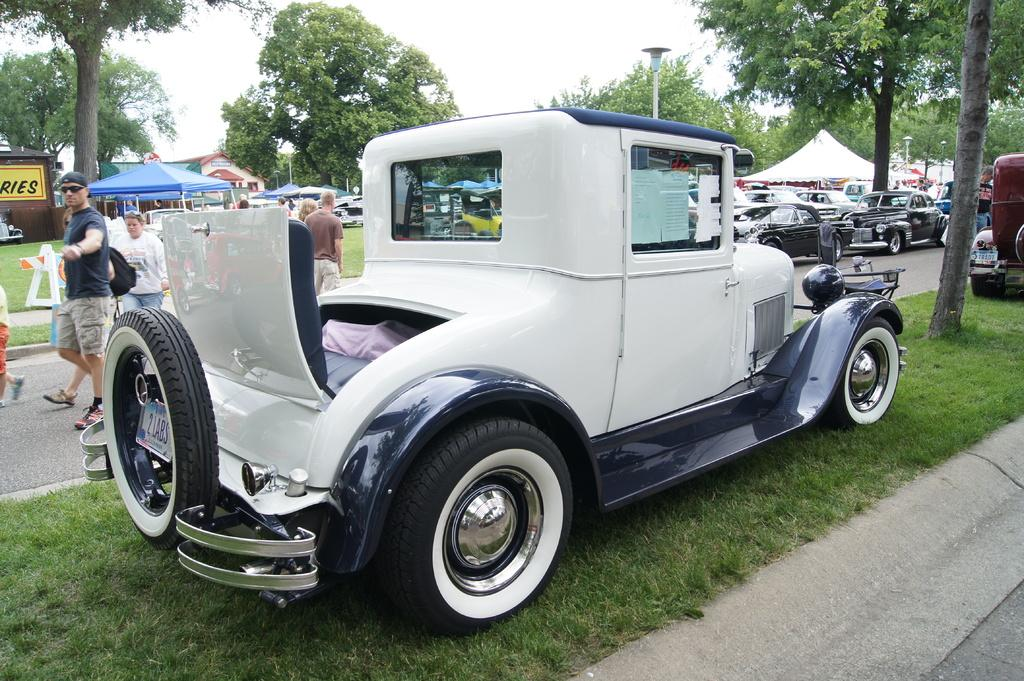What type of vehicles can be seen in the image? There are cars in the image. What type of temporary shelters are present in the image? There are tents in the image. What are the people in the image doing? There are people walking in the image. What type of vegetation is visible in the image? There are trees in the image. What is written on the board in the image? There is a board with text in the text in the image. What type of ground surface is visible in the image? There is grass on the ground in the image. What is the condition of the sky in the image? The sky is cloudy in the image. What type of cheese is being played by the band in the image? There is no band or cheese present in the image. In which direction are the people walking in the most in the image? The image does not provide information about the direction in which the people are walking. 